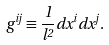Convert formula to latex. <formula><loc_0><loc_0><loc_500><loc_500>g ^ { i j } \equiv \frac { 1 } { l ^ { 2 } } d x ^ { i } d x ^ { j } .</formula> 